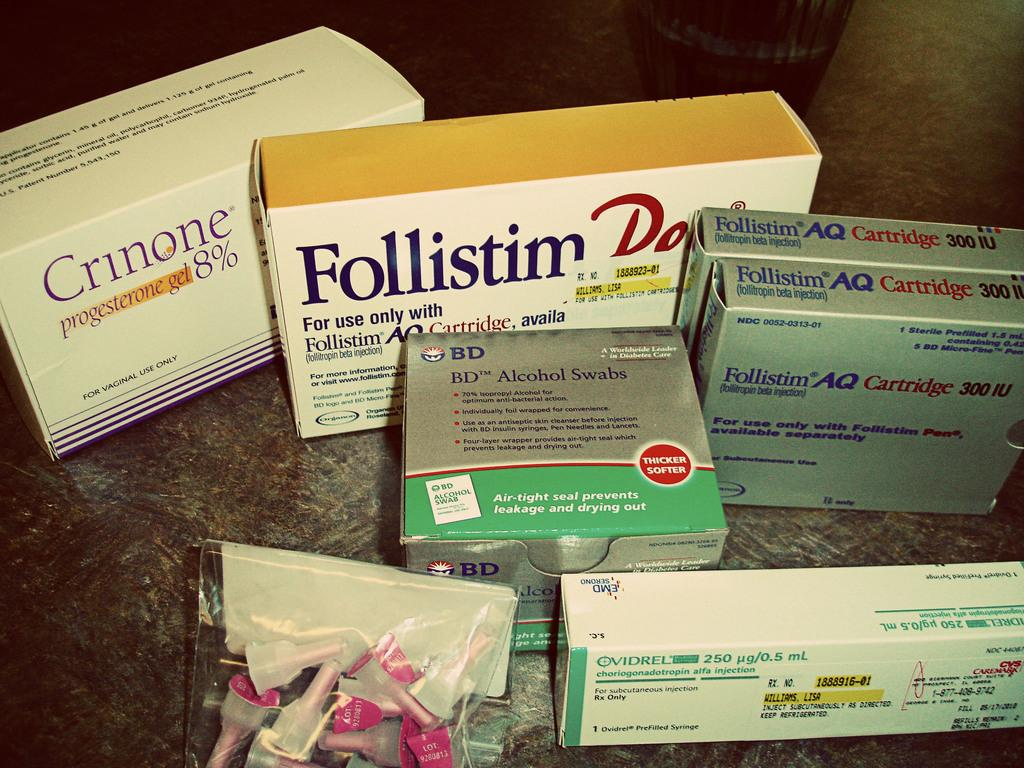<image>
Write a terse but informative summary of the picture. Boxes of Follistim injectable cartridges and a box of alcohol swabs. 